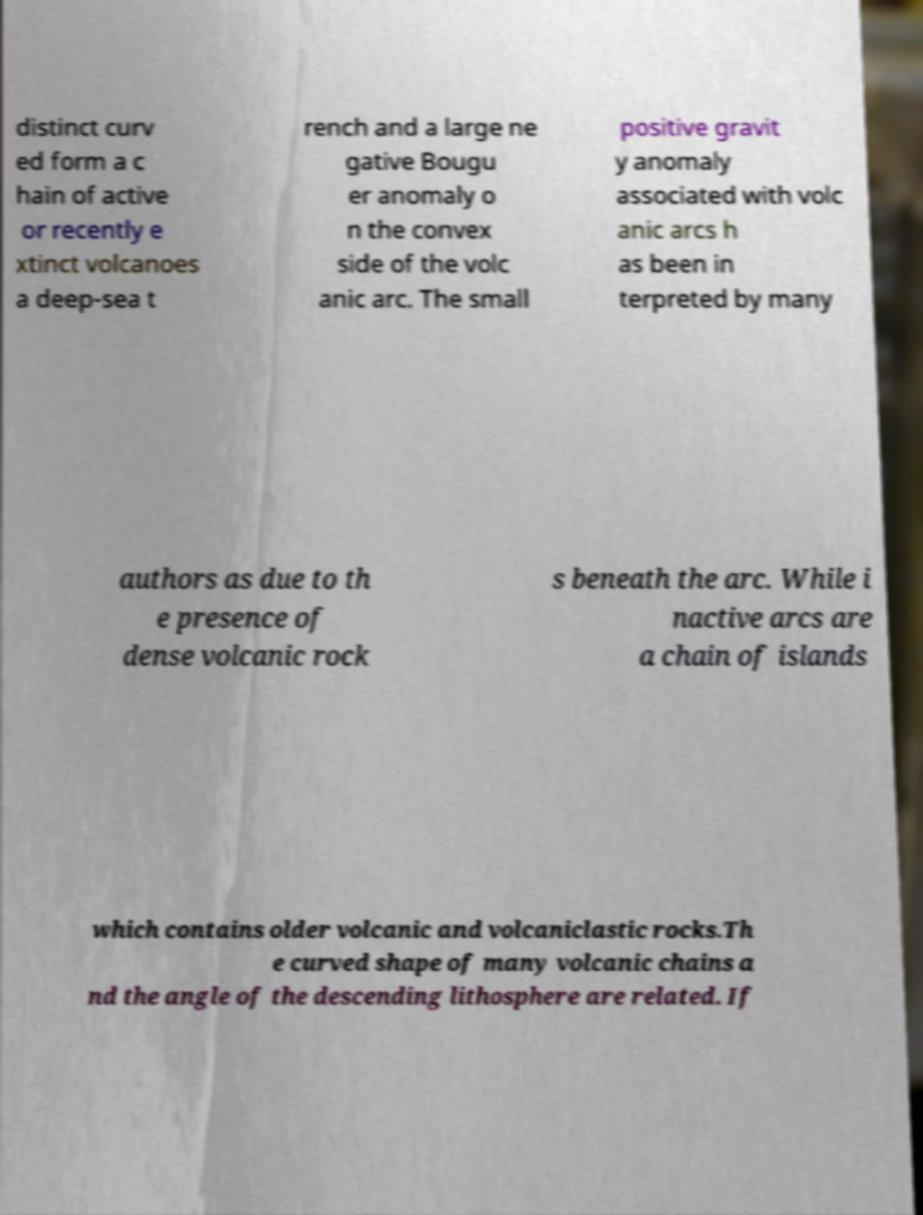What messages or text are displayed in this image? I need them in a readable, typed format. distinct curv ed form a c hain of active or recently e xtinct volcanoes a deep-sea t rench and a large ne gative Bougu er anomaly o n the convex side of the volc anic arc. The small positive gravit y anomaly associated with volc anic arcs h as been in terpreted by many authors as due to th e presence of dense volcanic rock s beneath the arc. While i nactive arcs are a chain of islands which contains older volcanic and volcaniclastic rocks.Th e curved shape of many volcanic chains a nd the angle of the descending lithosphere are related. If 